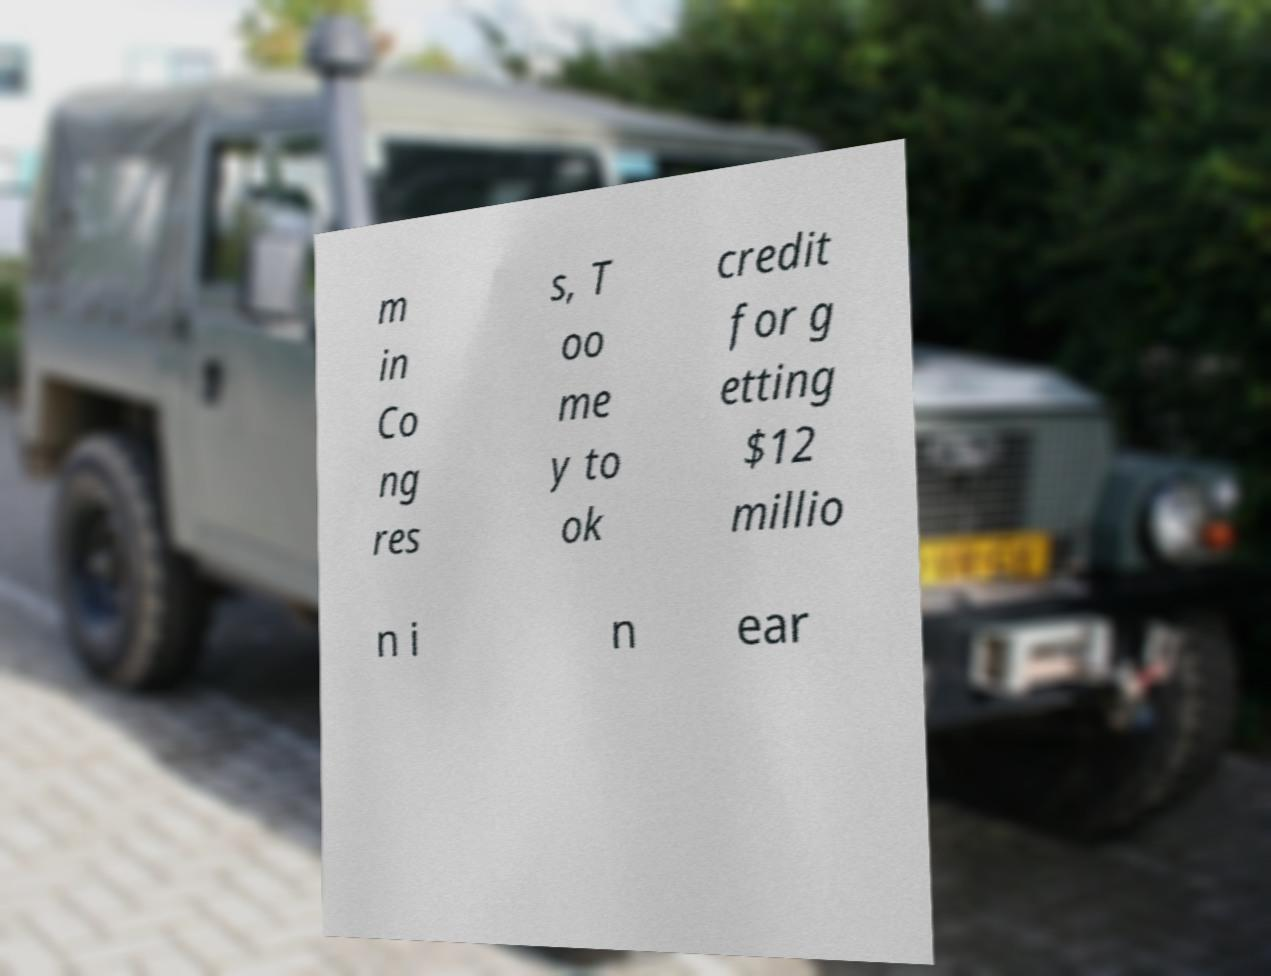For documentation purposes, I need the text within this image transcribed. Could you provide that? m in Co ng res s, T oo me y to ok credit for g etting $12 millio n i n ear 